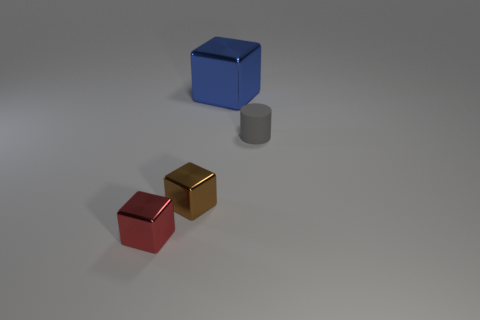There is a red object; is it the same size as the cube that is behind the gray matte cylinder? Upon close examination, the red object appears to be a smaller cube when compared to the blue cube positioned behind the gray matte cylinder. The red cube's dimensions are visibly less in all directions. 